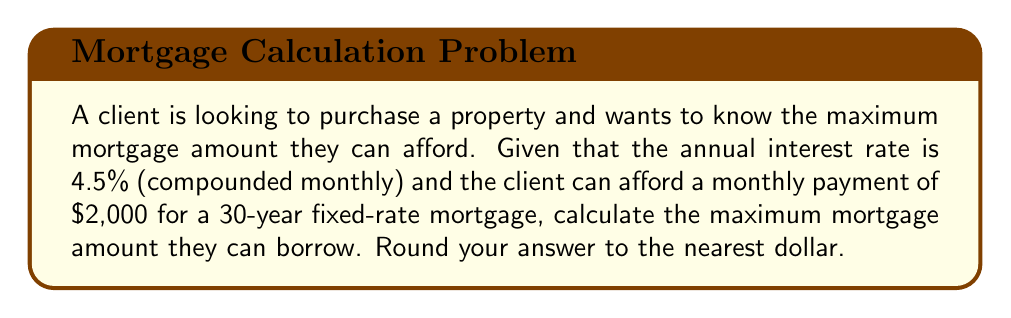Can you solve this math problem? Let's approach this step-by-step:

1) First, we need to use the mortgage payment formula:

   $$P = L \frac{r(1+r)^n}{(1+r)^n - 1}$$

   Where:
   $P$ = monthly payment
   $L$ = loan amount (what we're solving for)
   $r$ = monthly interest rate
   $n$ = total number of monthly payments

2) We know:
   $P = 2000$
   Annual interest rate = 4.5%
   $r = 0.045 / 12 = 0.00375$ (monthly rate)
   $n = 30 * 12 = 360$ (30 years of monthly payments)

3) Substituting these values:

   $$2000 = L \frac{0.00375(1+0.00375)^{360}}{(1+0.00375)^{360} - 1}$$

4) Let's simplify the right side of the equation:

   $$\frac{0.00375(1+0.00375)^{360}}{(1+0.00375)^{360} - 1} \approx 0.00506$$

5) Now our equation looks like:

   $$2000 = L * 0.00506$$

6) Solving for L:

   $$L = \frac{2000}{0.00506} \approx 395,256.92$$

7) Rounding to the nearest dollar:

   $$L = 395,257$$
Answer: $395,257 